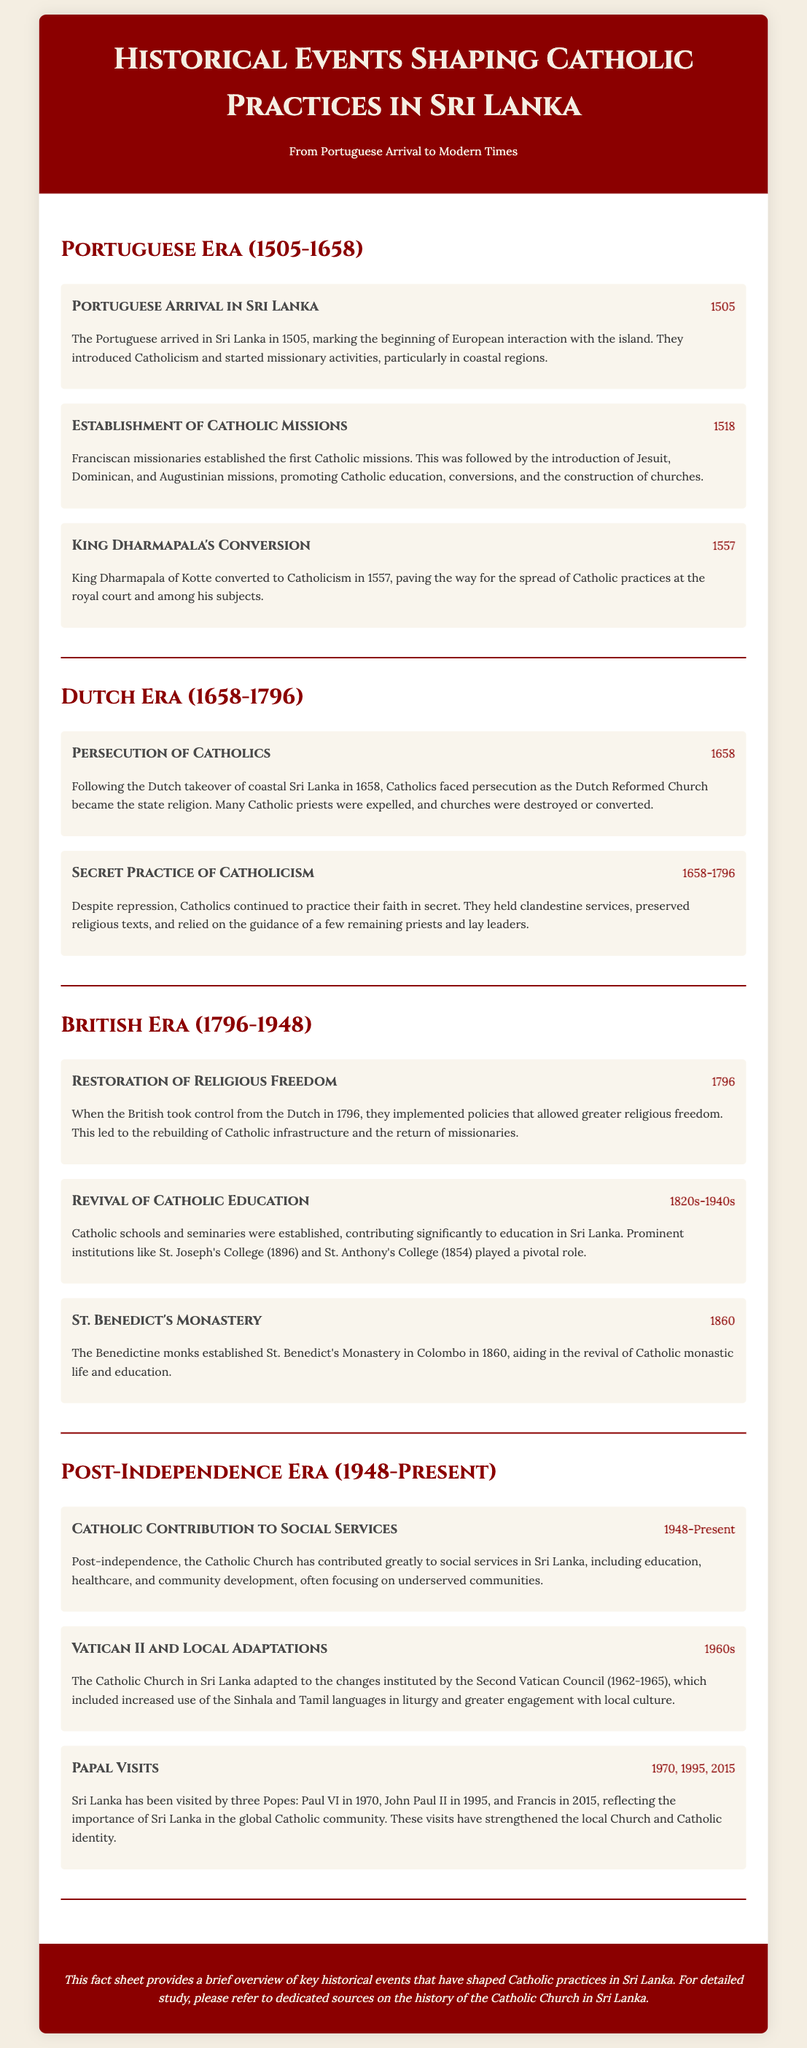what year did the Portuguese arrive in Sri Lanka? The document states that the Portuguese arrived in Sri Lanka in the year 1505.
Answer: 1505 who converted to Catholicism in 1557? The document mentions that King Dharmapala of Kotte converted to Catholicism in 1557.
Answer: King Dharmapala what was established by Franciscan missionaries in 1518? The document details that the establishment of Catholic missions occurred in 1518.
Answer: Catholic missions which religion became the state religion after the Dutch takeover? According to the document, the Dutch Reformed Church became the state religion after the takeover.
Answer: Dutch Reformed Church what year did the British take control from the Dutch? The document states that the British took control in 1796.
Answer: 1796 which educational institution was established in 1896? The document lists St. Joseph's College as the educational institution established in 1896.
Answer: St. Joseph's College how did the Catholic Church adapt in the 1960s? The document notes that the Catholic Church in Sri Lanka adapted by increasing the use of the Sinhala and Tamil languages in liturgy.
Answer: Sinhala and Tamil languages which Pope visited Sri Lanka in 1995? The document notes that Pope John Paul II visited Sri Lanka in 1995.
Answer: John Paul II 